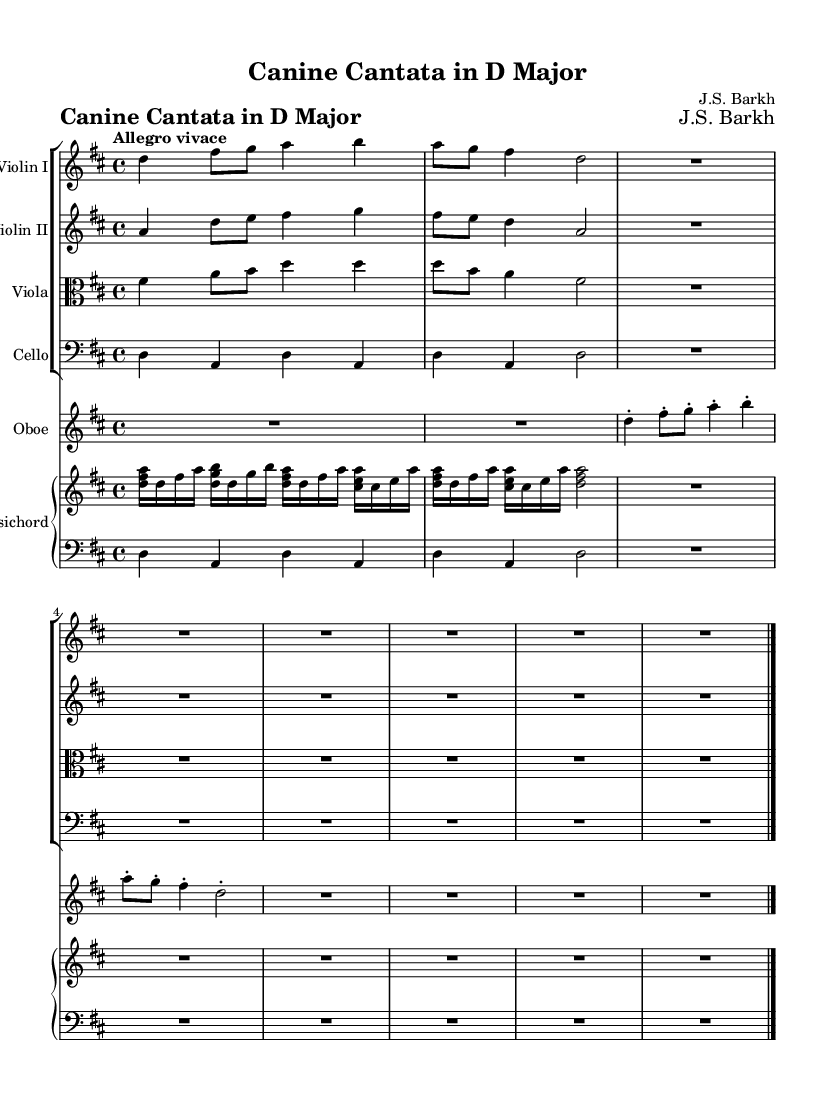What is the key signature of this music? The key signature is indicated after the clef at the beginning of the staff. The presence of two sharps (F# and C#) shows that the key is D major.
Answer: D major What is the time signature of this music? The time signature is typically found near the beginning of the staff, represented as a fraction. In this case, it is shown as 4/4, indicating four beats per measure.
Answer: 4/4 What is the tempo marking for this piece? The tempo marking is indicated at the beginning of the score, where it states "Allegro vivace." This tells musicians to play the piece lively and briskly.
Answer: Allegro vivace How many instruments are in this composition? By counting the distinct parts indicated in the score, there are a total of six unique instrument parts: two violins, one viola, one cello, one oboe, and one harpsichord.
Answer: Six Which instrument has a clef change? The viola part shows a clef change to alto, which is identified at the beginning of the viola staff in the score. This indicates the range of notes played by the viola.
Answer: Viola What type of composition does this piece represent? The title "Canine Cantata in D Major" suggests that this is a cantata, which is a type of vocal composition with instrumental accompaniment typical of the Baroque period.
Answer: Cantata 